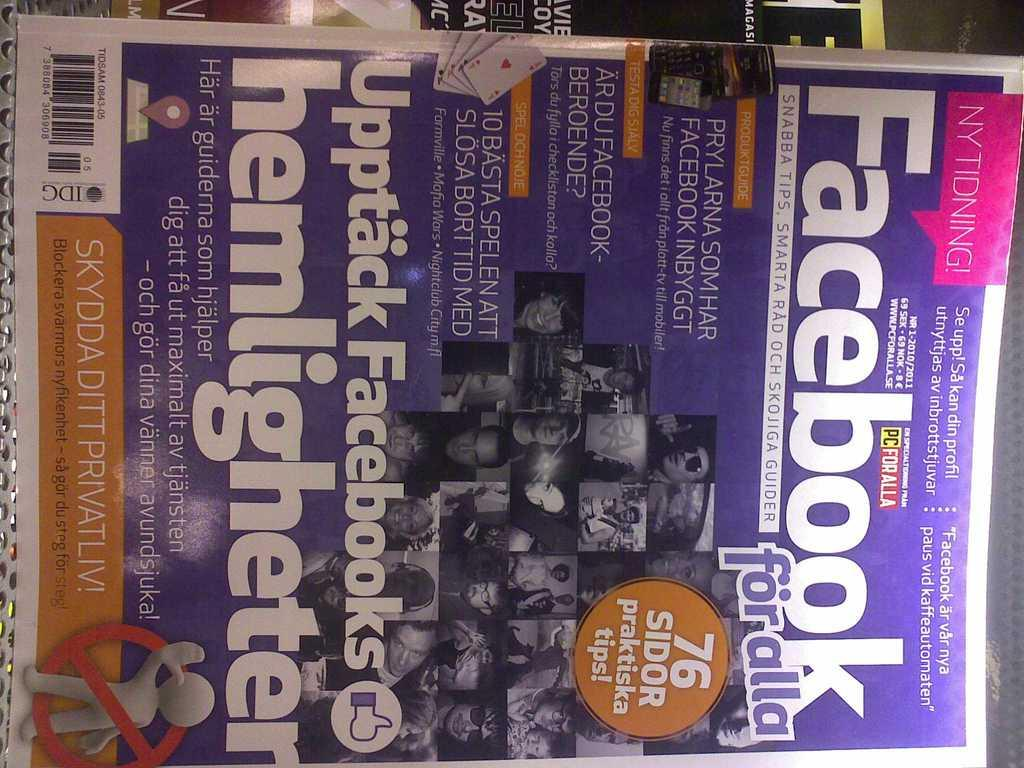Provide a one-sentence caption for the provided image. The magazine has several headlines in a foreign language with the only English word being Facebook. 